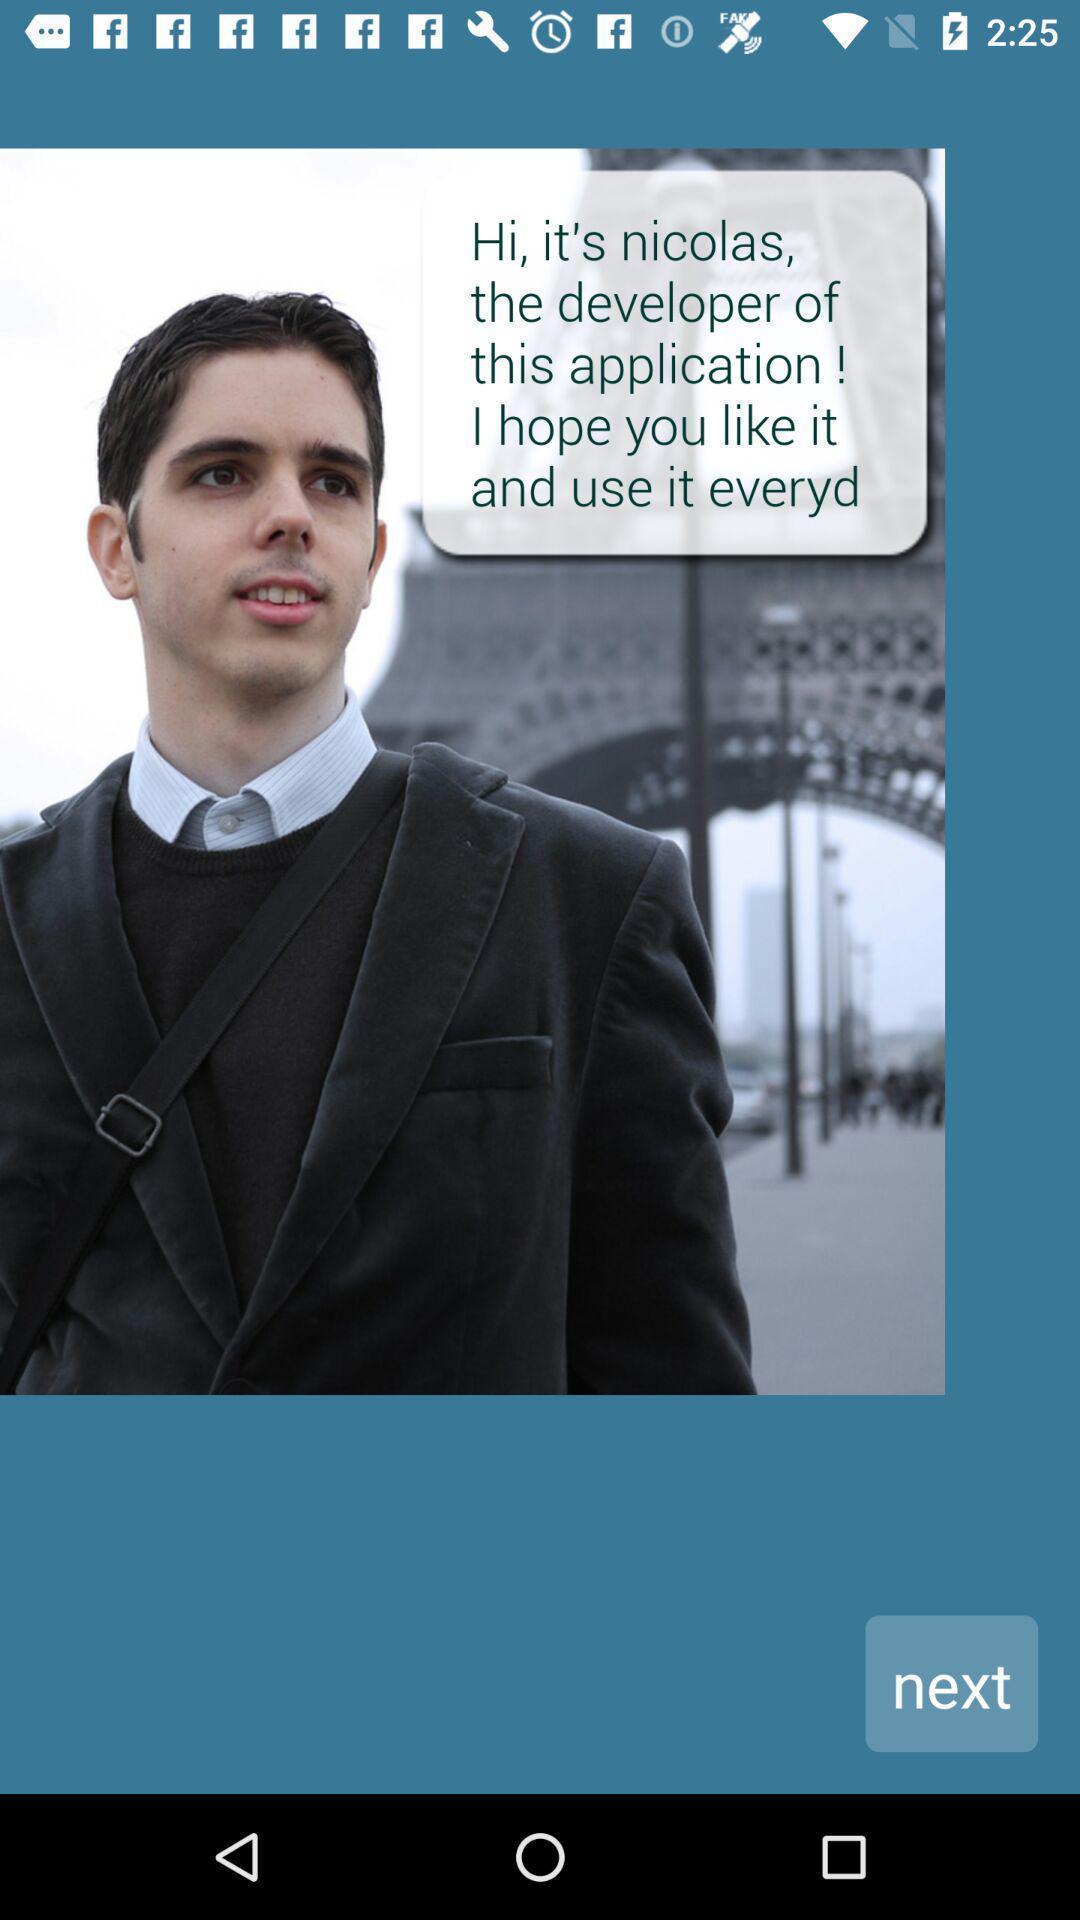Summarize the main components in this picture. Welcome page of an alarm app. 